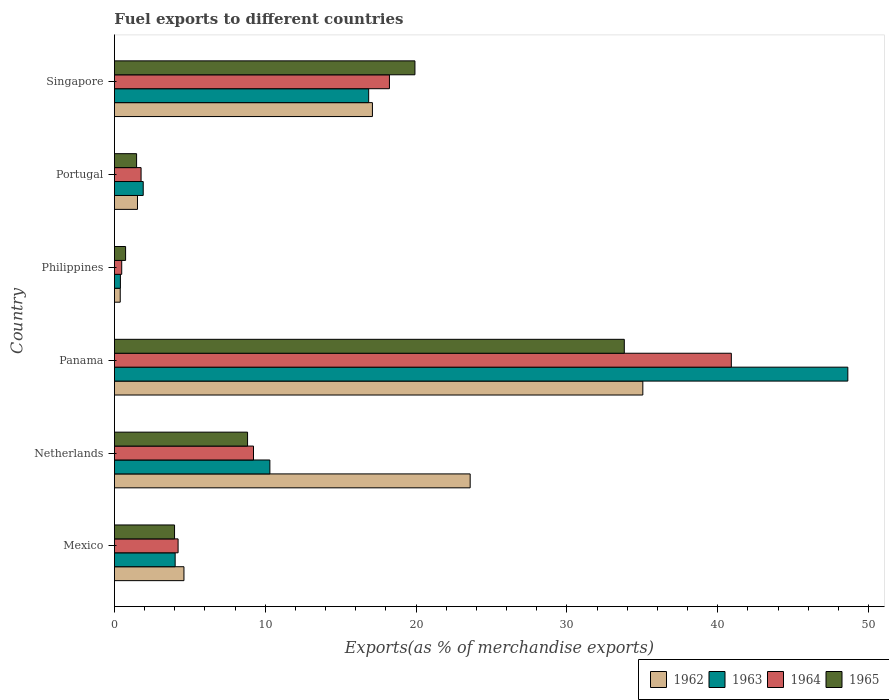How many groups of bars are there?
Give a very brief answer. 6. Are the number of bars on each tick of the Y-axis equal?
Provide a succinct answer. Yes. How many bars are there on the 3rd tick from the bottom?
Make the answer very short. 4. What is the percentage of exports to different countries in 1964 in Panama?
Offer a terse response. 40.9. Across all countries, what is the maximum percentage of exports to different countries in 1965?
Your answer should be very brief. 33.8. Across all countries, what is the minimum percentage of exports to different countries in 1963?
Offer a very short reply. 0.4. In which country was the percentage of exports to different countries in 1965 maximum?
Give a very brief answer. Panama. In which country was the percentage of exports to different countries in 1964 minimum?
Make the answer very short. Philippines. What is the total percentage of exports to different countries in 1963 in the graph?
Keep it short and to the point. 82.11. What is the difference between the percentage of exports to different countries in 1962 in Netherlands and that in Singapore?
Ensure brevity in your answer.  6.48. What is the difference between the percentage of exports to different countries in 1962 in Singapore and the percentage of exports to different countries in 1964 in Netherlands?
Offer a terse response. 7.88. What is the average percentage of exports to different countries in 1963 per country?
Ensure brevity in your answer.  13.69. What is the difference between the percentage of exports to different countries in 1965 and percentage of exports to different countries in 1964 in Philippines?
Make the answer very short. 0.26. In how many countries, is the percentage of exports to different countries in 1962 greater than 16 %?
Ensure brevity in your answer.  3. What is the ratio of the percentage of exports to different countries in 1964 in Panama to that in Philippines?
Give a very brief answer. 84.6. Is the difference between the percentage of exports to different countries in 1965 in Mexico and Portugal greater than the difference between the percentage of exports to different countries in 1964 in Mexico and Portugal?
Your answer should be very brief. Yes. What is the difference between the highest and the second highest percentage of exports to different countries in 1964?
Your response must be concise. 22.67. What is the difference between the highest and the lowest percentage of exports to different countries in 1962?
Keep it short and to the point. 34.64. What does the 2nd bar from the top in Mexico represents?
Your answer should be compact. 1964. What does the 2nd bar from the bottom in Netherlands represents?
Give a very brief answer. 1963. How many bars are there?
Offer a very short reply. 24. How many countries are there in the graph?
Offer a very short reply. 6. What is the difference between two consecutive major ticks on the X-axis?
Give a very brief answer. 10. Does the graph contain any zero values?
Your response must be concise. No. Does the graph contain grids?
Offer a very short reply. No. Where does the legend appear in the graph?
Your response must be concise. Bottom right. How are the legend labels stacked?
Your response must be concise. Horizontal. What is the title of the graph?
Your answer should be very brief. Fuel exports to different countries. Does "2005" appear as one of the legend labels in the graph?
Ensure brevity in your answer.  No. What is the label or title of the X-axis?
Your response must be concise. Exports(as % of merchandise exports). What is the Exports(as % of merchandise exports) of 1962 in Mexico?
Keep it short and to the point. 4.61. What is the Exports(as % of merchandise exports) in 1963 in Mexico?
Give a very brief answer. 4.03. What is the Exports(as % of merchandise exports) in 1964 in Mexico?
Your answer should be compact. 4.22. What is the Exports(as % of merchandise exports) in 1965 in Mexico?
Offer a terse response. 3.99. What is the Exports(as % of merchandise exports) in 1962 in Netherlands?
Offer a terse response. 23.58. What is the Exports(as % of merchandise exports) of 1963 in Netherlands?
Provide a succinct answer. 10.31. What is the Exports(as % of merchandise exports) of 1964 in Netherlands?
Offer a very short reply. 9.22. What is the Exports(as % of merchandise exports) of 1965 in Netherlands?
Keep it short and to the point. 8.83. What is the Exports(as % of merchandise exports) of 1962 in Panama?
Make the answer very short. 35.03. What is the Exports(as % of merchandise exports) in 1963 in Panama?
Provide a short and direct response. 48.62. What is the Exports(as % of merchandise exports) in 1964 in Panama?
Make the answer very short. 40.9. What is the Exports(as % of merchandise exports) in 1965 in Panama?
Provide a succinct answer. 33.8. What is the Exports(as % of merchandise exports) in 1962 in Philippines?
Provide a succinct answer. 0.38. What is the Exports(as % of merchandise exports) in 1963 in Philippines?
Provide a short and direct response. 0.4. What is the Exports(as % of merchandise exports) of 1964 in Philippines?
Ensure brevity in your answer.  0.48. What is the Exports(as % of merchandise exports) of 1965 in Philippines?
Your response must be concise. 0.74. What is the Exports(as % of merchandise exports) in 1962 in Portugal?
Your answer should be compact. 1.53. What is the Exports(as % of merchandise exports) in 1963 in Portugal?
Ensure brevity in your answer.  1.91. What is the Exports(as % of merchandise exports) of 1964 in Portugal?
Offer a very short reply. 1.77. What is the Exports(as % of merchandise exports) in 1965 in Portugal?
Offer a very short reply. 1.47. What is the Exports(as % of merchandise exports) of 1962 in Singapore?
Your answer should be very brief. 17.1. What is the Exports(as % of merchandise exports) of 1963 in Singapore?
Give a very brief answer. 16.85. What is the Exports(as % of merchandise exports) of 1964 in Singapore?
Provide a succinct answer. 18.23. What is the Exports(as % of merchandise exports) of 1965 in Singapore?
Offer a very short reply. 19.92. Across all countries, what is the maximum Exports(as % of merchandise exports) in 1962?
Provide a short and direct response. 35.03. Across all countries, what is the maximum Exports(as % of merchandise exports) of 1963?
Your answer should be compact. 48.62. Across all countries, what is the maximum Exports(as % of merchandise exports) of 1964?
Your response must be concise. 40.9. Across all countries, what is the maximum Exports(as % of merchandise exports) of 1965?
Your answer should be very brief. 33.8. Across all countries, what is the minimum Exports(as % of merchandise exports) in 1962?
Provide a short and direct response. 0.38. Across all countries, what is the minimum Exports(as % of merchandise exports) in 1963?
Provide a short and direct response. 0.4. Across all countries, what is the minimum Exports(as % of merchandise exports) in 1964?
Give a very brief answer. 0.48. Across all countries, what is the minimum Exports(as % of merchandise exports) of 1965?
Your answer should be compact. 0.74. What is the total Exports(as % of merchandise exports) in 1962 in the graph?
Provide a short and direct response. 82.24. What is the total Exports(as % of merchandise exports) in 1963 in the graph?
Make the answer very short. 82.11. What is the total Exports(as % of merchandise exports) of 1964 in the graph?
Provide a short and direct response. 74.82. What is the total Exports(as % of merchandise exports) of 1965 in the graph?
Provide a short and direct response. 68.74. What is the difference between the Exports(as % of merchandise exports) of 1962 in Mexico and that in Netherlands?
Make the answer very short. -18.97. What is the difference between the Exports(as % of merchandise exports) in 1963 in Mexico and that in Netherlands?
Your response must be concise. -6.28. What is the difference between the Exports(as % of merchandise exports) in 1964 in Mexico and that in Netherlands?
Give a very brief answer. -5. What is the difference between the Exports(as % of merchandise exports) of 1965 in Mexico and that in Netherlands?
Offer a very short reply. -4.84. What is the difference between the Exports(as % of merchandise exports) of 1962 in Mexico and that in Panama?
Keep it short and to the point. -30.42. What is the difference between the Exports(as % of merchandise exports) in 1963 in Mexico and that in Panama?
Your answer should be compact. -44.59. What is the difference between the Exports(as % of merchandise exports) in 1964 in Mexico and that in Panama?
Provide a short and direct response. -36.68. What is the difference between the Exports(as % of merchandise exports) in 1965 in Mexico and that in Panama?
Provide a short and direct response. -29.82. What is the difference between the Exports(as % of merchandise exports) in 1962 in Mexico and that in Philippines?
Your response must be concise. 4.22. What is the difference between the Exports(as % of merchandise exports) in 1963 in Mexico and that in Philippines?
Your answer should be very brief. 3.63. What is the difference between the Exports(as % of merchandise exports) of 1964 in Mexico and that in Philippines?
Your answer should be compact. 3.74. What is the difference between the Exports(as % of merchandise exports) in 1965 in Mexico and that in Philippines?
Ensure brevity in your answer.  3.25. What is the difference between the Exports(as % of merchandise exports) of 1962 in Mexico and that in Portugal?
Your answer should be compact. 3.08. What is the difference between the Exports(as % of merchandise exports) of 1963 in Mexico and that in Portugal?
Your answer should be compact. 2.12. What is the difference between the Exports(as % of merchandise exports) of 1964 in Mexico and that in Portugal?
Provide a succinct answer. 2.45. What is the difference between the Exports(as % of merchandise exports) in 1965 in Mexico and that in Portugal?
Provide a succinct answer. 2.52. What is the difference between the Exports(as % of merchandise exports) in 1962 in Mexico and that in Singapore?
Your answer should be compact. -12.49. What is the difference between the Exports(as % of merchandise exports) of 1963 in Mexico and that in Singapore?
Offer a very short reply. -12.83. What is the difference between the Exports(as % of merchandise exports) of 1964 in Mexico and that in Singapore?
Make the answer very short. -14.01. What is the difference between the Exports(as % of merchandise exports) in 1965 in Mexico and that in Singapore?
Provide a short and direct response. -15.94. What is the difference between the Exports(as % of merchandise exports) in 1962 in Netherlands and that in Panama?
Your answer should be very brief. -11.45. What is the difference between the Exports(as % of merchandise exports) of 1963 in Netherlands and that in Panama?
Keep it short and to the point. -38.32. What is the difference between the Exports(as % of merchandise exports) of 1964 in Netherlands and that in Panama?
Make the answer very short. -31.68. What is the difference between the Exports(as % of merchandise exports) in 1965 in Netherlands and that in Panama?
Make the answer very short. -24.98. What is the difference between the Exports(as % of merchandise exports) in 1962 in Netherlands and that in Philippines?
Keep it short and to the point. 23.2. What is the difference between the Exports(as % of merchandise exports) of 1963 in Netherlands and that in Philippines?
Ensure brevity in your answer.  9.91. What is the difference between the Exports(as % of merchandise exports) in 1964 in Netherlands and that in Philippines?
Ensure brevity in your answer.  8.74. What is the difference between the Exports(as % of merchandise exports) of 1965 in Netherlands and that in Philippines?
Offer a very short reply. 8.09. What is the difference between the Exports(as % of merchandise exports) of 1962 in Netherlands and that in Portugal?
Make the answer very short. 22.06. What is the difference between the Exports(as % of merchandise exports) in 1963 in Netherlands and that in Portugal?
Provide a succinct answer. 8.4. What is the difference between the Exports(as % of merchandise exports) in 1964 in Netherlands and that in Portugal?
Your answer should be compact. 7.45. What is the difference between the Exports(as % of merchandise exports) of 1965 in Netherlands and that in Portugal?
Your response must be concise. 7.36. What is the difference between the Exports(as % of merchandise exports) in 1962 in Netherlands and that in Singapore?
Keep it short and to the point. 6.48. What is the difference between the Exports(as % of merchandise exports) of 1963 in Netherlands and that in Singapore?
Your answer should be compact. -6.55. What is the difference between the Exports(as % of merchandise exports) of 1964 in Netherlands and that in Singapore?
Provide a succinct answer. -9.01. What is the difference between the Exports(as % of merchandise exports) of 1965 in Netherlands and that in Singapore?
Offer a terse response. -11.1. What is the difference between the Exports(as % of merchandise exports) in 1962 in Panama and that in Philippines?
Provide a succinct answer. 34.65. What is the difference between the Exports(as % of merchandise exports) of 1963 in Panama and that in Philippines?
Provide a succinct answer. 48.22. What is the difference between the Exports(as % of merchandise exports) in 1964 in Panama and that in Philippines?
Your answer should be compact. 40.41. What is the difference between the Exports(as % of merchandise exports) of 1965 in Panama and that in Philippines?
Your answer should be very brief. 33.06. What is the difference between the Exports(as % of merchandise exports) of 1962 in Panama and that in Portugal?
Keep it short and to the point. 33.5. What is the difference between the Exports(as % of merchandise exports) of 1963 in Panama and that in Portugal?
Provide a succinct answer. 46.71. What is the difference between the Exports(as % of merchandise exports) in 1964 in Panama and that in Portugal?
Your response must be concise. 39.13. What is the difference between the Exports(as % of merchandise exports) in 1965 in Panama and that in Portugal?
Offer a terse response. 32.33. What is the difference between the Exports(as % of merchandise exports) in 1962 in Panama and that in Singapore?
Your answer should be very brief. 17.93. What is the difference between the Exports(as % of merchandise exports) of 1963 in Panama and that in Singapore?
Provide a succinct answer. 31.77. What is the difference between the Exports(as % of merchandise exports) in 1964 in Panama and that in Singapore?
Provide a short and direct response. 22.67. What is the difference between the Exports(as % of merchandise exports) of 1965 in Panama and that in Singapore?
Ensure brevity in your answer.  13.88. What is the difference between the Exports(as % of merchandise exports) of 1962 in Philippines and that in Portugal?
Provide a short and direct response. -1.14. What is the difference between the Exports(as % of merchandise exports) in 1963 in Philippines and that in Portugal?
Make the answer very short. -1.51. What is the difference between the Exports(as % of merchandise exports) of 1964 in Philippines and that in Portugal?
Ensure brevity in your answer.  -1.28. What is the difference between the Exports(as % of merchandise exports) of 1965 in Philippines and that in Portugal?
Keep it short and to the point. -0.73. What is the difference between the Exports(as % of merchandise exports) in 1962 in Philippines and that in Singapore?
Your answer should be very brief. -16.72. What is the difference between the Exports(as % of merchandise exports) in 1963 in Philippines and that in Singapore?
Provide a short and direct response. -16.46. What is the difference between the Exports(as % of merchandise exports) of 1964 in Philippines and that in Singapore?
Your answer should be very brief. -17.75. What is the difference between the Exports(as % of merchandise exports) of 1965 in Philippines and that in Singapore?
Provide a short and direct response. -19.18. What is the difference between the Exports(as % of merchandise exports) of 1962 in Portugal and that in Singapore?
Ensure brevity in your answer.  -15.58. What is the difference between the Exports(as % of merchandise exports) of 1963 in Portugal and that in Singapore?
Give a very brief answer. -14.95. What is the difference between the Exports(as % of merchandise exports) in 1964 in Portugal and that in Singapore?
Ensure brevity in your answer.  -16.47. What is the difference between the Exports(as % of merchandise exports) of 1965 in Portugal and that in Singapore?
Offer a very short reply. -18.45. What is the difference between the Exports(as % of merchandise exports) in 1962 in Mexico and the Exports(as % of merchandise exports) in 1963 in Netherlands?
Offer a terse response. -5.7. What is the difference between the Exports(as % of merchandise exports) in 1962 in Mexico and the Exports(as % of merchandise exports) in 1964 in Netherlands?
Your answer should be very brief. -4.61. What is the difference between the Exports(as % of merchandise exports) in 1962 in Mexico and the Exports(as % of merchandise exports) in 1965 in Netherlands?
Ensure brevity in your answer.  -4.22. What is the difference between the Exports(as % of merchandise exports) of 1963 in Mexico and the Exports(as % of merchandise exports) of 1964 in Netherlands?
Make the answer very short. -5.19. What is the difference between the Exports(as % of merchandise exports) in 1963 in Mexico and the Exports(as % of merchandise exports) in 1965 in Netherlands?
Make the answer very short. -4.8. What is the difference between the Exports(as % of merchandise exports) of 1964 in Mexico and the Exports(as % of merchandise exports) of 1965 in Netherlands?
Provide a short and direct response. -4.61. What is the difference between the Exports(as % of merchandise exports) of 1962 in Mexico and the Exports(as % of merchandise exports) of 1963 in Panama?
Your answer should be very brief. -44.01. What is the difference between the Exports(as % of merchandise exports) in 1962 in Mexico and the Exports(as % of merchandise exports) in 1964 in Panama?
Ensure brevity in your answer.  -36.29. What is the difference between the Exports(as % of merchandise exports) of 1962 in Mexico and the Exports(as % of merchandise exports) of 1965 in Panama?
Your answer should be compact. -29.19. What is the difference between the Exports(as % of merchandise exports) in 1963 in Mexico and the Exports(as % of merchandise exports) in 1964 in Panama?
Provide a succinct answer. -36.87. What is the difference between the Exports(as % of merchandise exports) in 1963 in Mexico and the Exports(as % of merchandise exports) in 1965 in Panama?
Offer a terse response. -29.78. What is the difference between the Exports(as % of merchandise exports) in 1964 in Mexico and the Exports(as % of merchandise exports) in 1965 in Panama?
Offer a very short reply. -29.58. What is the difference between the Exports(as % of merchandise exports) in 1962 in Mexico and the Exports(as % of merchandise exports) in 1963 in Philippines?
Provide a succinct answer. 4.21. What is the difference between the Exports(as % of merchandise exports) in 1962 in Mexico and the Exports(as % of merchandise exports) in 1964 in Philippines?
Keep it short and to the point. 4.13. What is the difference between the Exports(as % of merchandise exports) of 1962 in Mexico and the Exports(as % of merchandise exports) of 1965 in Philippines?
Offer a very short reply. 3.87. What is the difference between the Exports(as % of merchandise exports) in 1963 in Mexico and the Exports(as % of merchandise exports) in 1964 in Philippines?
Keep it short and to the point. 3.54. What is the difference between the Exports(as % of merchandise exports) of 1963 in Mexico and the Exports(as % of merchandise exports) of 1965 in Philippines?
Keep it short and to the point. 3.29. What is the difference between the Exports(as % of merchandise exports) of 1964 in Mexico and the Exports(as % of merchandise exports) of 1965 in Philippines?
Your answer should be very brief. 3.48. What is the difference between the Exports(as % of merchandise exports) in 1962 in Mexico and the Exports(as % of merchandise exports) in 1963 in Portugal?
Your answer should be very brief. 2.7. What is the difference between the Exports(as % of merchandise exports) in 1962 in Mexico and the Exports(as % of merchandise exports) in 1964 in Portugal?
Your response must be concise. 2.84. What is the difference between the Exports(as % of merchandise exports) of 1962 in Mexico and the Exports(as % of merchandise exports) of 1965 in Portugal?
Give a very brief answer. 3.14. What is the difference between the Exports(as % of merchandise exports) in 1963 in Mexico and the Exports(as % of merchandise exports) in 1964 in Portugal?
Offer a very short reply. 2.26. What is the difference between the Exports(as % of merchandise exports) in 1963 in Mexico and the Exports(as % of merchandise exports) in 1965 in Portugal?
Make the answer very short. 2.56. What is the difference between the Exports(as % of merchandise exports) in 1964 in Mexico and the Exports(as % of merchandise exports) in 1965 in Portugal?
Ensure brevity in your answer.  2.75. What is the difference between the Exports(as % of merchandise exports) of 1962 in Mexico and the Exports(as % of merchandise exports) of 1963 in Singapore?
Your response must be concise. -12.25. What is the difference between the Exports(as % of merchandise exports) of 1962 in Mexico and the Exports(as % of merchandise exports) of 1964 in Singapore?
Your answer should be very brief. -13.62. What is the difference between the Exports(as % of merchandise exports) in 1962 in Mexico and the Exports(as % of merchandise exports) in 1965 in Singapore?
Keep it short and to the point. -15.31. What is the difference between the Exports(as % of merchandise exports) in 1963 in Mexico and the Exports(as % of merchandise exports) in 1964 in Singapore?
Provide a short and direct response. -14.21. What is the difference between the Exports(as % of merchandise exports) in 1963 in Mexico and the Exports(as % of merchandise exports) in 1965 in Singapore?
Keep it short and to the point. -15.9. What is the difference between the Exports(as % of merchandise exports) of 1964 in Mexico and the Exports(as % of merchandise exports) of 1965 in Singapore?
Ensure brevity in your answer.  -15.7. What is the difference between the Exports(as % of merchandise exports) in 1962 in Netherlands and the Exports(as % of merchandise exports) in 1963 in Panama?
Your response must be concise. -25.04. What is the difference between the Exports(as % of merchandise exports) of 1962 in Netherlands and the Exports(as % of merchandise exports) of 1964 in Panama?
Make the answer very short. -17.31. What is the difference between the Exports(as % of merchandise exports) in 1962 in Netherlands and the Exports(as % of merchandise exports) in 1965 in Panama?
Your response must be concise. -10.22. What is the difference between the Exports(as % of merchandise exports) of 1963 in Netherlands and the Exports(as % of merchandise exports) of 1964 in Panama?
Your answer should be compact. -30.59. What is the difference between the Exports(as % of merchandise exports) in 1963 in Netherlands and the Exports(as % of merchandise exports) in 1965 in Panama?
Offer a very short reply. -23.5. What is the difference between the Exports(as % of merchandise exports) of 1964 in Netherlands and the Exports(as % of merchandise exports) of 1965 in Panama?
Ensure brevity in your answer.  -24.58. What is the difference between the Exports(as % of merchandise exports) in 1962 in Netherlands and the Exports(as % of merchandise exports) in 1963 in Philippines?
Provide a short and direct response. 23.19. What is the difference between the Exports(as % of merchandise exports) of 1962 in Netherlands and the Exports(as % of merchandise exports) of 1964 in Philippines?
Keep it short and to the point. 23.1. What is the difference between the Exports(as % of merchandise exports) in 1962 in Netherlands and the Exports(as % of merchandise exports) in 1965 in Philippines?
Your answer should be very brief. 22.84. What is the difference between the Exports(as % of merchandise exports) of 1963 in Netherlands and the Exports(as % of merchandise exports) of 1964 in Philippines?
Offer a terse response. 9.82. What is the difference between the Exports(as % of merchandise exports) in 1963 in Netherlands and the Exports(as % of merchandise exports) in 1965 in Philippines?
Offer a very short reply. 9.57. What is the difference between the Exports(as % of merchandise exports) of 1964 in Netherlands and the Exports(as % of merchandise exports) of 1965 in Philippines?
Make the answer very short. 8.48. What is the difference between the Exports(as % of merchandise exports) of 1962 in Netherlands and the Exports(as % of merchandise exports) of 1963 in Portugal?
Provide a short and direct response. 21.68. What is the difference between the Exports(as % of merchandise exports) in 1962 in Netherlands and the Exports(as % of merchandise exports) in 1964 in Portugal?
Your answer should be very brief. 21.82. What is the difference between the Exports(as % of merchandise exports) in 1962 in Netherlands and the Exports(as % of merchandise exports) in 1965 in Portugal?
Provide a succinct answer. 22.11. What is the difference between the Exports(as % of merchandise exports) of 1963 in Netherlands and the Exports(as % of merchandise exports) of 1964 in Portugal?
Give a very brief answer. 8.54. What is the difference between the Exports(as % of merchandise exports) of 1963 in Netherlands and the Exports(as % of merchandise exports) of 1965 in Portugal?
Your response must be concise. 8.84. What is the difference between the Exports(as % of merchandise exports) in 1964 in Netherlands and the Exports(as % of merchandise exports) in 1965 in Portugal?
Give a very brief answer. 7.75. What is the difference between the Exports(as % of merchandise exports) of 1962 in Netherlands and the Exports(as % of merchandise exports) of 1963 in Singapore?
Provide a short and direct response. 6.73. What is the difference between the Exports(as % of merchandise exports) of 1962 in Netherlands and the Exports(as % of merchandise exports) of 1964 in Singapore?
Keep it short and to the point. 5.35. What is the difference between the Exports(as % of merchandise exports) in 1962 in Netherlands and the Exports(as % of merchandise exports) in 1965 in Singapore?
Offer a very short reply. 3.66. What is the difference between the Exports(as % of merchandise exports) in 1963 in Netherlands and the Exports(as % of merchandise exports) in 1964 in Singapore?
Provide a succinct answer. -7.93. What is the difference between the Exports(as % of merchandise exports) in 1963 in Netherlands and the Exports(as % of merchandise exports) in 1965 in Singapore?
Keep it short and to the point. -9.62. What is the difference between the Exports(as % of merchandise exports) in 1964 in Netherlands and the Exports(as % of merchandise exports) in 1965 in Singapore?
Offer a terse response. -10.7. What is the difference between the Exports(as % of merchandise exports) of 1962 in Panama and the Exports(as % of merchandise exports) of 1963 in Philippines?
Provide a succinct answer. 34.63. What is the difference between the Exports(as % of merchandise exports) in 1962 in Panama and the Exports(as % of merchandise exports) in 1964 in Philippines?
Keep it short and to the point. 34.55. What is the difference between the Exports(as % of merchandise exports) in 1962 in Panama and the Exports(as % of merchandise exports) in 1965 in Philippines?
Provide a short and direct response. 34.29. What is the difference between the Exports(as % of merchandise exports) in 1963 in Panama and the Exports(as % of merchandise exports) in 1964 in Philippines?
Make the answer very short. 48.14. What is the difference between the Exports(as % of merchandise exports) of 1963 in Panama and the Exports(as % of merchandise exports) of 1965 in Philippines?
Give a very brief answer. 47.88. What is the difference between the Exports(as % of merchandise exports) in 1964 in Panama and the Exports(as % of merchandise exports) in 1965 in Philippines?
Ensure brevity in your answer.  40.16. What is the difference between the Exports(as % of merchandise exports) of 1962 in Panama and the Exports(as % of merchandise exports) of 1963 in Portugal?
Give a very brief answer. 33.12. What is the difference between the Exports(as % of merchandise exports) of 1962 in Panama and the Exports(as % of merchandise exports) of 1964 in Portugal?
Offer a very short reply. 33.26. What is the difference between the Exports(as % of merchandise exports) of 1962 in Panama and the Exports(as % of merchandise exports) of 1965 in Portugal?
Keep it short and to the point. 33.56. What is the difference between the Exports(as % of merchandise exports) of 1963 in Panama and the Exports(as % of merchandise exports) of 1964 in Portugal?
Your response must be concise. 46.85. What is the difference between the Exports(as % of merchandise exports) in 1963 in Panama and the Exports(as % of merchandise exports) in 1965 in Portugal?
Ensure brevity in your answer.  47.15. What is the difference between the Exports(as % of merchandise exports) of 1964 in Panama and the Exports(as % of merchandise exports) of 1965 in Portugal?
Offer a terse response. 39.43. What is the difference between the Exports(as % of merchandise exports) in 1962 in Panama and the Exports(as % of merchandise exports) in 1963 in Singapore?
Provide a succinct answer. 18.18. What is the difference between the Exports(as % of merchandise exports) of 1962 in Panama and the Exports(as % of merchandise exports) of 1964 in Singapore?
Provide a short and direct response. 16.8. What is the difference between the Exports(as % of merchandise exports) in 1962 in Panama and the Exports(as % of merchandise exports) in 1965 in Singapore?
Your answer should be compact. 15.11. What is the difference between the Exports(as % of merchandise exports) of 1963 in Panama and the Exports(as % of merchandise exports) of 1964 in Singapore?
Keep it short and to the point. 30.39. What is the difference between the Exports(as % of merchandise exports) of 1963 in Panama and the Exports(as % of merchandise exports) of 1965 in Singapore?
Offer a very short reply. 28.7. What is the difference between the Exports(as % of merchandise exports) in 1964 in Panama and the Exports(as % of merchandise exports) in 1965 in Singapore?
Offer a very short reply. 20.98. What is the difference between the Exports(as % of merchandise exports) of 1962 in Philippines and the Exports(as % of merchandise exports) of 1963 in Portugal?
Your answer should be very brief. -1.52. What is the difference between the Exports(as % of merchandise exports) of 1962 in Philippines and the Exports(as % of merchandise exports) of 1964 in Portugal?
Your answer should be compact. -1.38. What is the difference between the Exports(as % of merchandise exports) in 1962 in Philippines and the Exports(as % of merchandise exports) in 1965 in Portugal?
Offer a terse response. -1.08. What is the difference between the Exports(as % of merchandise exports) in 1963 in Philippines and the Exports(as % of merchandise exports) in 1964 in Portugal?
Your answer should be very brief. -1.37. What is the difference between the Exports(as % of merchandise exports) in 1963 in Philippines and the Exports(as % of merchandise exports) in 1965 in Portugal?
Keep it short and to the point. -1.07. What is the difference between the Exports(as % of merchandise exports) of 1964 in Philippines and the Exports(as % of merchandise exports) of 1965 in Portugal?
Provide a succinct answer. -0.99. What is the difference between the Exports(as % of merchandise exports) of 1962 in Philippines and the Exports(as % of merchandise exports) of 1963 in Singapore?
Provide a short and direct response. -16.47. What is the difference between the Exports(as % of merchandise exports) in 1962 in Philippines and the Exports(as % of merchandise exports) in 1964 in Singapore?
Ensure brevity in your answer.  -17.85. What is the difference between the Exports(as % of merchandise exports) of 1962 in Philippines and the Exports(as % of merchandise exports) of 1965 in Singapore?
Keep it short and to the point. -19.54. What is the difference between the Exports(as % of merchandise exports) of 1963 in Philippines and the Exports(as % of merchandise exports) of 1964 in Singapore?
Ensure brevity in your answer.  -17.84. What is the difference between the Exports(as % of merchandise exports) of 1963 in Philippines and the Exports(as % of merchandise exports) of 1965 in Singapore?
Give a very brief answer. -19.53. What is the difference between the Exports(as % of merchandise exports) in 1964 in Philippines and the Exports(as % of merchandise exports) in 1965 in Singapore?
Your response must be concise. -19.44. What is the difference between the Exports(as % of merchandise exports) in 1962 in Portugal and the Exports(as % of merchandise exports) in 1963 in Singapore?
Provide a short and direct response. -15.33. What is the difference between the Exports(as % of merchandise exports) of 1962 in Portugal and the Exports(as % of merchandise exports) of 1964 in Singapore?
Your answer should be compact. -16.7. What is the difference between the Exports(as % of merchandise exports) of 1962 in Portugal and the Exports(as % of merchandise exports) of 1965 in Singapore?
Keep it short and to the point. -18.39. What is the difference between the Exports(as % of merchandise exports) in 1963 in Portugal and the Exports(as % of merchandise exports) in 1964 in Singapore?
Provide a short and direct response. -16.32. What is the difference between the Exports(as % of merchandise exports) in 1963 in Portugal and the Exports(as % of merchandise exports) in 1965 in Singapore?
Your answer should be compact. -18.01. What is the difference between the Exports(as % of merchandise exports) of 1964 in Portugal and the Exports(as % of merchandise exports) of 1965 in Singapore?
Offer a terse response. -18.16. What is the average Exports(as % of merchandise exports) of 1962 per country?
Offer a very short reply. 13.71. What is the average Exports(as % of merchandise exports) in 1963 per country?
Offer a terse response. 13.69. What is the average Exports(as % of merchandise exports) of 1964 per country?
Provide a succinct answer. 12.47. What is the average Exports(as % of merchandise exports) in 1965 per country?
Your answer should be compact. 11.46. What is the difference between the Exports(as % of merchandise exports) in 1962 and Exports(as % of merchandise exports) in 1963 in Mexico?
Your answer should be compact. 0.58. What is the difference between the Exports(as % of merchandise exports) in 1962 and Exports(as % of merchandise exports) in 1964 in Mexico?
Keep it short and to the point. 0.39. What is the difference between the Exports(as % of merchandise exports) in 1962 and Exports(as % of merchandise exports) in 1965 in Mexico?
Provide a short and direct response. 0.62. What is the difference between the Exports(as % of merchandise exports) of 1963 and Exports(as % of merchandise exports) of 1964 in Mexico?
Give a very brief answer. -0.19. What is the difference between the Exports(as % of merchandise exports) of 1963 and Exports(as % of merchandise exports) of 1965 in Mexico?
Your answer should be very brief. 0.04. What is the difference between the Exports(as % of merchandise exports) in 1964 and Exports(as % of merchandise exports) in 1965 in Mexico?
Keep it short and to the point. 0.23. What is the difference between the Exports(as % of merchandise exports) of 1962 and Exports(as % of merchandise exports) of 1963 in Netherlands?
Your answer should be very brief. 13.28. What is the difference between the Exports(as % of merchandise exports) of 1962 and Exports(as % of merchandise exports) of 1964 in Netherlands?
Offer a very short reply. 14.36. What is the difference between the Exports(as % of merchandise exports) in 1962 and Exports(as % of merchandise exports) in 1965 in Netherlands?
Provide a short and direct response. 14.76. What is the difference between the Exports(as % of merchandise exports) in 1963 and Exports(as % of merchandise exports) in 1964 in Netherlands?
Your answer should be very brief. 1.09. What is the difference between the Exports(as % of merchandise exports) of 1963 and Exports(as % of merchandise exports) of 1965 in Netherlands?
Give a very brief answer. 1.48. What is the difference between the Exports(as % of merchandise exports) of 1964 and Exports(as % of merchandise exports) of 1965 in Netherlands?
Offer a terse response. 0.39. What is the difference between the Exports(as % of merchandise exports) of 1962 and Exports(as % of merchandise exports) of 1963 in Panama?
Ensure brevity in your answer.  -13.59. What is the difference between the Exports(as % of merchandise exports) of 1962 and Exports(as % of merchandise exports) of 1964 in Panama?
Ensure brevity in your answer.  -5.87. What is the difference between the Exports(as % of merchandise exports) of 1962 and Exports(as % of merchandise exports) of 1965 in Panama?
Your response must be concise. 1.23. What is the difference between the Exports(as % of merchandise exports) in 1963 and Exports(as % of merchandise exports) in 1964 in Panama?
Offer a terse response. 7.72. What is the difference between the Exports(as % of merchandise exports) in 1963 and Exports(as % of merchandise exports) in 1965 in Panama?
Provide a succinct answer. 14.82. What is the difference between the Exports(as % of merchandise exports) in 1964 and Exports(as % of merchandise exports) in 1965 in Panama?
Offer a terse response. 7.1. What is the difference between the Exports(as % of merchandise exports) in 1962 and Exports(as % of merchandise exports) in 1963 in Philippines?
Provide a short and direct response. -0.01. What is the difference between the Exports(as % of merchandise exports) of 1962 and Exports(as % of merchandise exports) of 1964 in Philippines?
Keep it short and to the point. -0.1. What is the difference between the Exports(as % of merchandise exports) of 1962 and Exports(as % of merchandise exports) of 1965 in Philippines?
Keep it short and to the point. -0.35. What is the difference between the Exports(as % of merchandise exports) of 1963 and Exports(as % of merchandise exports) of 1964 in Philippines?
Ensure brevity in your answer.  -0.09. What is the difference between the Exports(as % of merchandise exports) in 1963 and Exports(as % of merchandise exports) in 1965 in Philippines?
Ensure brevity in your answer.  -0.34. What is the difference between the Exports(as % of merchandise exports) of 1964 and Exports(as % of merchandise exports) of 1965 in Philippines?
Offer a very short reply. -0.26. What is the difference between the Exports(as % of merchandise exports) in 1962 and Exports(as % of merchandise exports) in 1963 in Portugal?
Provide a succinct answer. -0.38. What is the difference between the Exports(as % of merchandise exports) of 1962 and Exports(as % of merchandise exports) of 1964 in Portugal?
Your response must be concise. -0.24. What is the difference between the Exports(as % of merchandise exports) in 1962 and Exports(as % of merchandise exports) in 1965 in Portugal?
Your response must be concise. 0.06. What is the difference between the Exports(as % of merchandise exports) of 1963 and Exports(as % of merchandise exports) of 1964 in Portugal?
Give a very brief answer. 0.14. What is the difference between the Exports(as % of merchandise exports) in 1963 and Exports(as % of merchandise exports) in 1965 in Portugal?
Give a very brief answer. 0.44. What is the difference between the Exports(as % of merchandise exports) in 1964 and Exports(as % of merchandise exports) in 1965 in Portugal?
Your answer should be very brief. 0.3. What is the difference between the Exports(as % of merchandise exports) in 1962 and Exports(as % of merchandise exports) in 1963 in Singapore?
Provide a succinct answer. 0.25. What is the difference between the Exports(as % of merchandise exports) of 1962 and Exports(as % of merchandise exports) of 1964 in Singapore?
Provide a short and direct response. -1.13. What is the difference between the Exports(as % of merchandise exports) of 1962 and Exports(as % of merchandise exports) of 1965 in Singapore?
Your answer should be compact. -2.82. What is the difference between the Exports(as % of merchandise exports) in 1963 and Exports(as % of merchandise exports) in 1964 in Singapore?
Provide a succinct answer. -1.38. What is the difference between the Exports(as % of merchandise exports) in 1963 and Exports(as % of merchandise exports) in 1965 in Singapore?
Ensure brevity in your answer.  -3.07. What is the difference between the Exports(as % of merchandise exports) of 1964 and Exports(as % of merchandise exports) of 1965 in Singapore?
Your response must be concise. -1.69. What is the ratio of the Exports(as % of merchandise exports) in 1962 in Mexico to that in Netherlands?
Provide a succinct answer. 0.2. What is the ratio of the Exports(as % of merchandise exports) in 1963 in Mexico to that in Netherlands?
Give a very brief answer. 0.39. What is the ratio of the Exports(as % of merchandise exports) of 1964 in Mexico to that in Netherlands?
Provide a succinct answer. 0.46. What is the ratio of the Exports(as % of merchandise exports) in 1965 in Mexico to that in Netherlands?
Make the answer very short. 0.45. What is the ratio of the Exports(as % of merchandise exports) in 1962 in Mexico to that in Panama?
Your answer should be very brief. 0.13. What is the ratio of the Exports(as % of merchandise exports) of 1963 in Mexico to that in Panama?
Your response must be concise. 0.08. What is the ratio of the Exports(as % of merchandise exports) of 1964 in Mexico to that in Panama?
Your answer should be compact. 0.1. What is the ratio of the Exports(as % of merchandise exports) of 1965 in Mexico to that in Panama?
Your answer should be compact. 0.12. What is the ratio of the Exports(as % of merchandise exports) in 1962 in Mexico to that in Philippines?
Your answer should be very brief. 11.97. What is the ratio of the Exports(as % of merchandise exports) in 1963 in Mexico to that in Philippines?
Your response must be concise. 10.17. What is the ratio of the Exports(as % of merchandise exports) of 1964 in Mexico to that in Philippines?
Make the answer very short. 8.73. What is the ratio of the Exports(as % of merchandise exports) of 1965 in Mexico to that in Philippines?
Offer a very short reply. 5.39. What is the ratio of the Exports(as % of merchandise exports) of 1962 in Mexico to that in Portugal?
Make the answer very short. 3.02. What is the ratio of the Exports(as % of merchandise exports) of 1963 in Mexico to that in Portugal?
Make the answer very short. 2.11. What is the ratio of the Exports(as % of merchandise exports) in 1964 in Mexico to that in Portugal?
Your answer should be compact. 2.39. What is the ratio of the Exports(as % of merchandise exports) in 1965 in Mexico to that in Portugal?
Offer a terse response. 2.71. What is the ratio of the Exports(as % of merchandise exports) of 1962 in Mexico to that in Singapore?
Your answer should be compact. 0.27. What is the ratio of the Exports(as % of merchandise exports) of 1963 in Mexico to that in Singapore?
Give a very brief answer. 0.24. What is the ratio of the Exports(as % of merchandise exports) in 1964 in Mexico to that in Singapore?
Offer a terse response. 0.23. What is the ratio of the Exports(as % of merchandise exports) of 1965 in Mexico to that in Singapore?
Give a very brief answer. 0.2. What is the ratio of the Exports(as % of merchandise exports) in 1962 in Netherlands to that in Panama?
Your response must be concise. 0.67. What is the ratio of the Exports(as % of merchandise exports) in 1963 in Netherlands to that in Panama?
Give a very brief answer. 0.21. What is the ratio of the Exports(as % of merchandise exports) in 1964 in Netherlands to that in Panama?
Your answer should be very brief. 0.23. What is the ratio of the Exports(as % of merchandise exports) of 1965 in Netherlands to that in Panama?
Keep it short and to the point. 0.26. What is the ratio of the Exports(as % of merchandise exports) of 1962 in Netherlands to that in Philippines?
Ensure brevity in your answer.  61.27. What is the ratio of the Exports(as % of merchandise exports) of 1963 in Netherlands to that in Philippines?
Your response must be concise. 26.03. What is the ratio of the Exports(as % of merchandise exports) in 1964 in Netherlands to that in Philippines?
Ensure brevity in your answer.  19.07. What is the ratio of the Exports(as % of merchandise exports) in 1965 in Netherlands to that in Philippines?
Keep it short and to the point. 11.93. What is the ratio of the Exports(as % of merchandise exports) of 1962 in Netherlands to that in Portugal?
Provide a succinct answer. 15.43. What is the ratio of the Exports(as % of merchandise exports) of 1963 in Netherlands to that in Portugal?
Your answer should be compact. 5.4. What is the ratio of the Exports(as % of merchandise exports) of 1964 in Netherlands to that in Portugal?
Ensure brevity in your answer.  5.22. What is the ratio of the Exports(as % of merchandise exports) in 1965 in Netherlands to that in Portugal?
Your response must be concise. 6.01. What is the ratio of the Exports(as % of merchandise exports) of 1962 in Netherlands to that in Singapore?
Make the answer very short. 1.38. What is the ratio of the Exports(as % of merchandise exports) in 1963 in Netherlands to that in Singapore?
Offer a very short reply. 0.61. What is the ratio of the Exports(as % of merchandise exports) of 1964 in Netherlands to that in Singapore?
Offer a terse response. 0.51. What is the ratio of the Exports(as % of merchandise exports) in 1965 in Netherlands to that in Singapore?
Offer a terse response. 0.44. What is the ratio of the Exports(as % of merchandise exports) of 1962 in Panama to that in Philippines?
Offer a terse response. 91.01. What is the ratio of the Exports(as % of merchandise exports) in 1963 in Panama to that in Philippines?
Make the answer very short. 122.82. What is the ratio of the Exports(as % of merchandise exports) in 1964 in Panama to that in Philippines?
Keep it short and to the point. 84.6. What is the ratio of the Exports(as % of merchandise exports) in 1965 in Panama to that in Philippines?
Make the answer very short. 45.69. What is the ratio of the Exports(as % of merchandise exports) in 1962 in Panama to that in Portugal?
Keep it short and to the point. 22.92. What is the ratio of the Exports(as % of merchandise exports) in 1963 in Panama to that in Portugal?
Make the answer very short. 25.47. What is the ratio of the Exports(as % of merchandise exports) in 1964 in Panama to that in Portugal?
Keep it short and to the point. 23.15. What is the ratio of the Exports(as % of merchandise exports) in 1965 in Panama to that in Portugal?
Provide a succinct answer. 23. What is the ratio of the Exports(as % of merchandise exports) in 1962 in Panama to that in Singapore?
Your answer should be compact. 2.05. What is the ratio of the Exports(as % of merchandise exports) of 1963 in Panama to that in Singapore?
Ensure brevity in your answer.  2.88. What is the ratio of the Exports(as % of merchandise exports) of 1964 in Panama to that in Singapore?
Your answer should be very brief. 2.24. What is the ratio of the Exports(as % of merchandise exports) of 1965 in Panama to that in Singapore?
Your answer should be very brief. 1.7. What is the ratio of the Exports(as % of merchandise exports) of 1962 in Philippines to that in Portugal?
Offer a very short reply. 0.25. What is the ratio of the Exports(as % of merchandise exports) in 1963 in Philippines to that in Portugal?
Your answer should be compact. 0.21. What is the ratio of the Exports(as % of merchandise exports) of 1964 in Philippines to that in Portugal?
Your response must be concise. 0.27. What is the ratio of the Exports(as % of merchandise exports) in 1965 in Philippines to that in Portugal?
Your answer should be very brief. 0.5. What is the ratio of the Exports(as % of merchandise exports) in 1962 in Philippines to that in Singapore?
Keep it short and to the point. 0.02. What is the ratio of the Exports(as % of merchandise exports) of 1963 in Philippines to that in Singapore?
Ensure brevity in your answer.  0.02. What is the ratio of the Exports(as % of merchandise exports) in 1964 in Philippines to that in Singapore?
Your answer should be compact. 0.03. What is the ratio of the Exports(as % of merchandise exports) of 1965 in Philippines to that in Singapore?
Your response must be concise. 0.04. What is the ratio of the Exports(as % of merchandise exports) in 1962 in Portugal to that in Singapore?
Offer a terse response. 0.09. What is the ratio of the Exports(as % of merchandise exports) in 1963 in Portugal to that in Singapore?
Keep it short and to the point. 0.11. What is the ratio of the Exports(as % of merchandise exports) of 1964 in Portugal to that in Singapore?
Your answer should be very brief. 0.1. What is the ratio of the Exports(as % of merchandise exports) in 1965 in Portugal to that in Singapore?
Your response must be concise. 0.07. What is the difference between the highest and the second highest Exports(as % of merchandise exports) in 1962?
Provide a short and direct response. 11.45. What is the difference between the highest and the second highest Exports(as % of merchandise exports) in 1963?
Your response must be concise. 31.77. What is the difference between the highest and the second highest Exports(as % of merchandise exports) in 1964?
Offer a terse response. 22.67. What is the difference between the highest and the second highest Exports(as % of merchandise exports) in 1965?
Provide a short and direct response. 13.88. What is the difference between the highest and the lowest Exports(as % of merchandise exports) of 1962?
Your answer should be compact. 34.65. What is the difference between the highest and the lowest Exports(as % of merchandise exports) in 1963?
Give a very brief answer. 48.22. What is the difference between the highest and the lowest Exports(as % of merchandise exports) of 1964?
Provide a succinct answer. 40.41. What is the difference between the highest and the lowest Exports(as % of merchandise exports) of 1965?
Ensure brevity in your answer.  33.06. 